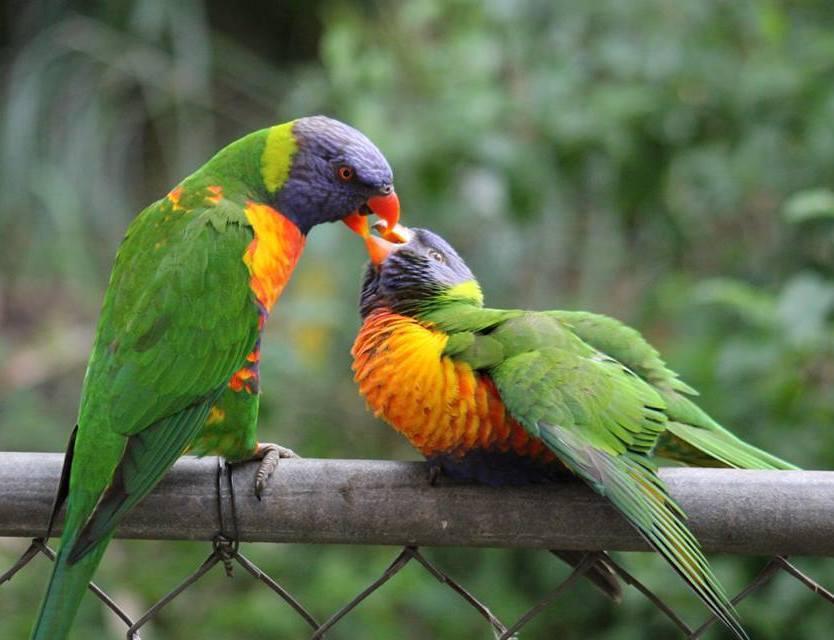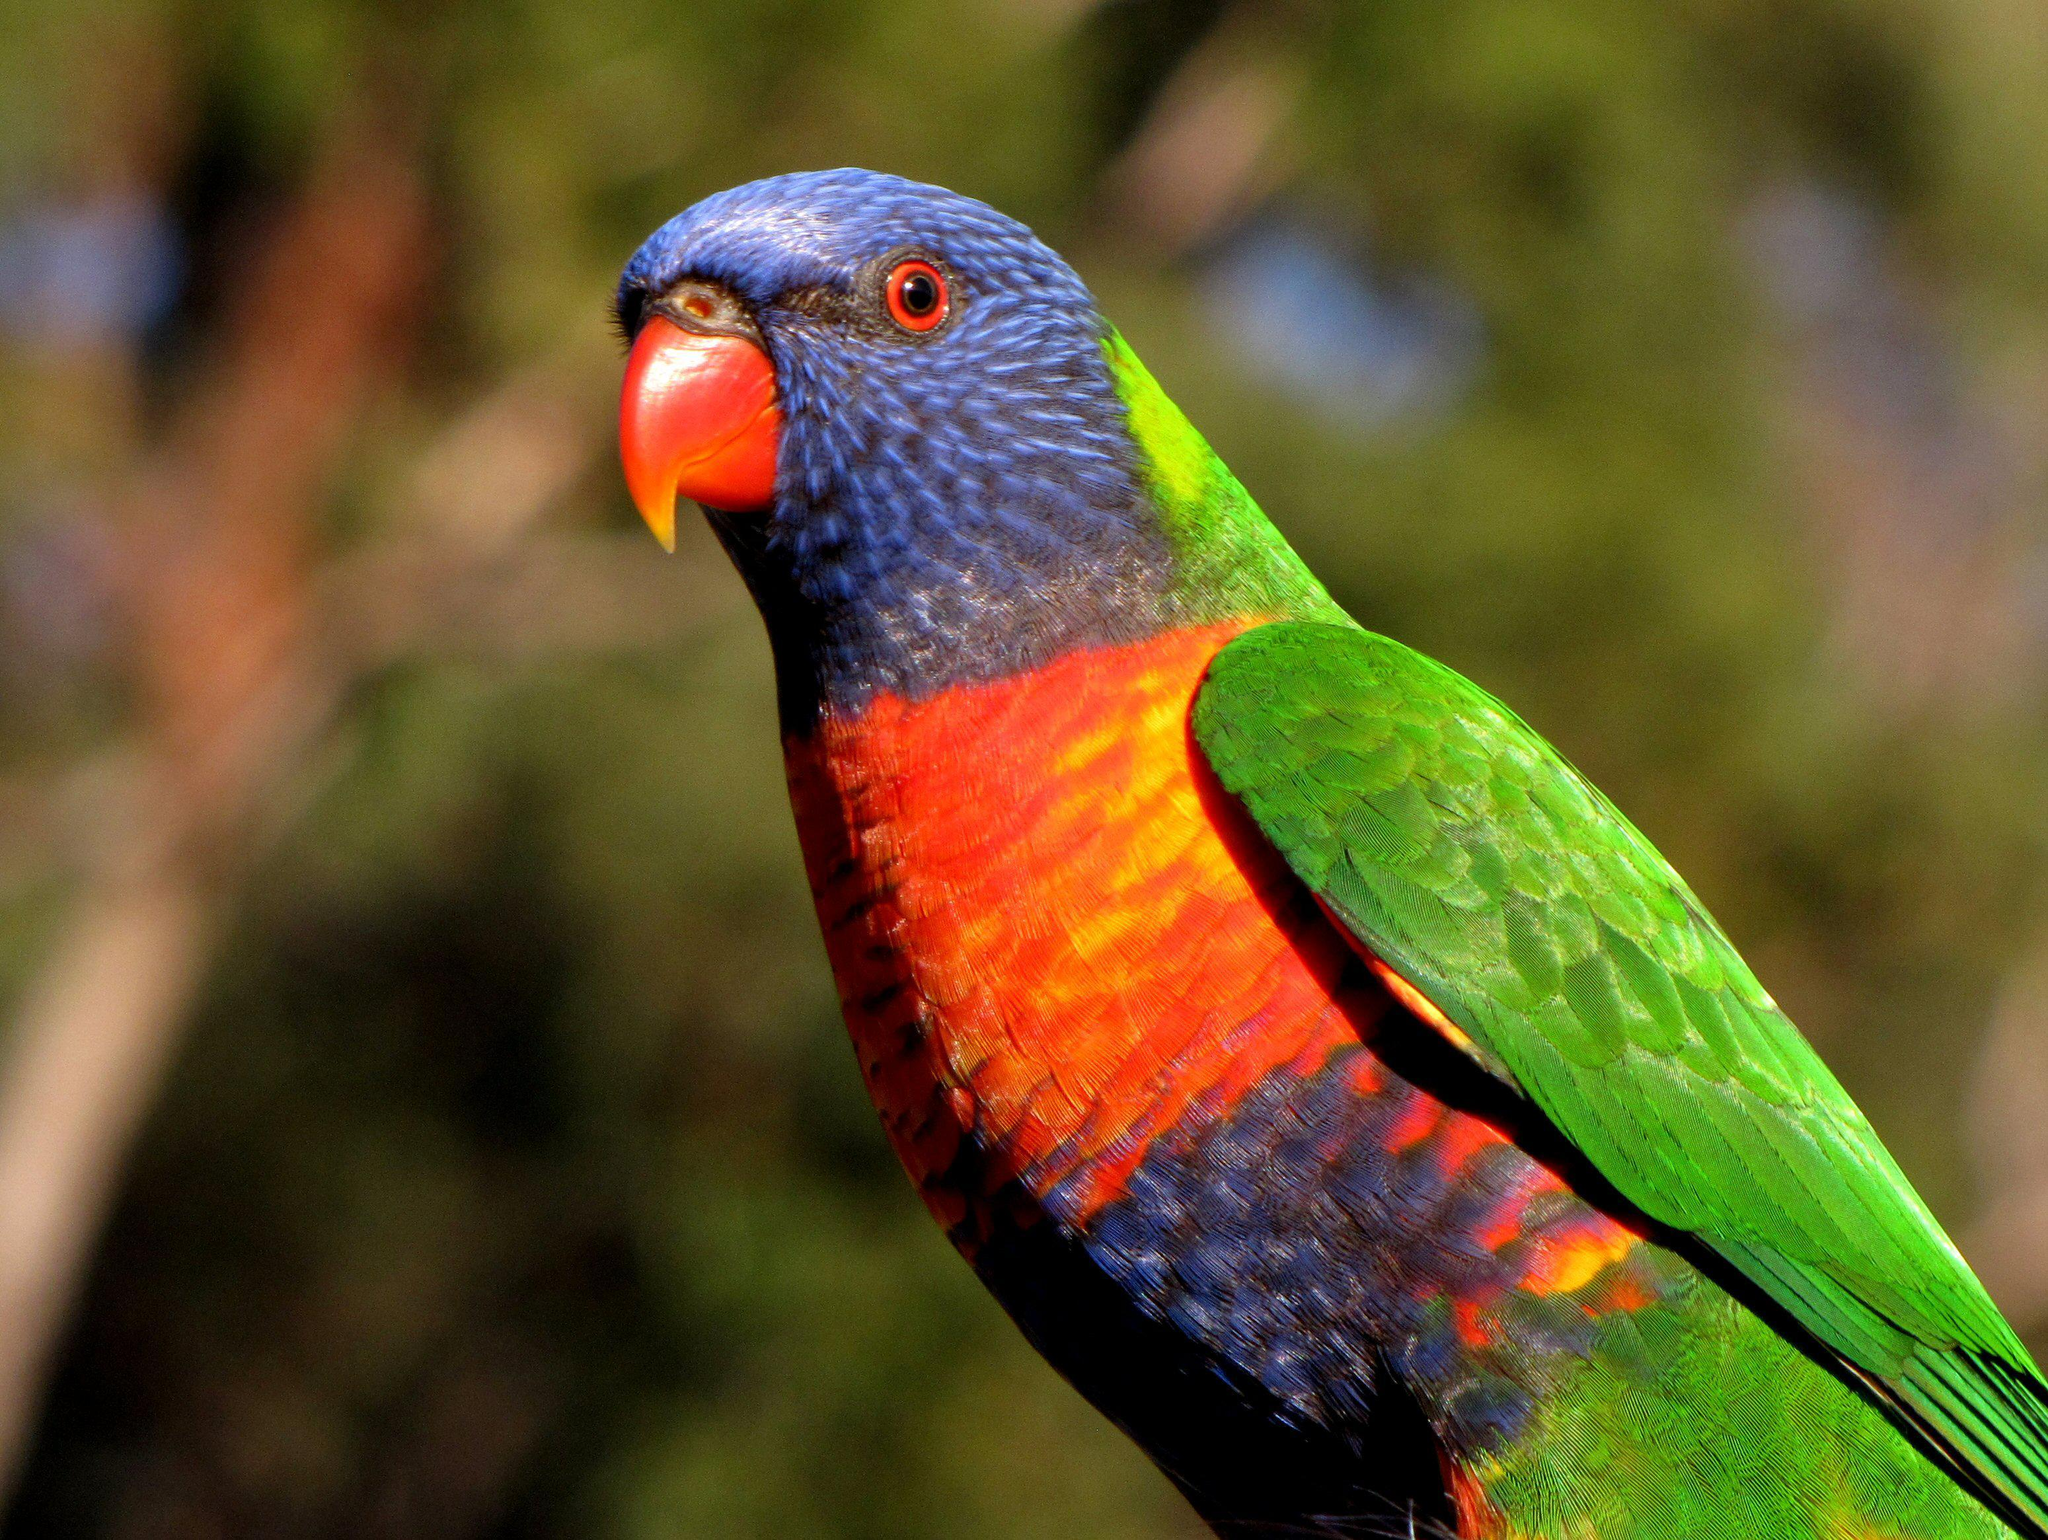The first image is the image on the left, the second image is the image on the right. Examine the images to the left and right. Is the description "There are three birds" accurate? Answer yes or no. Yes. 